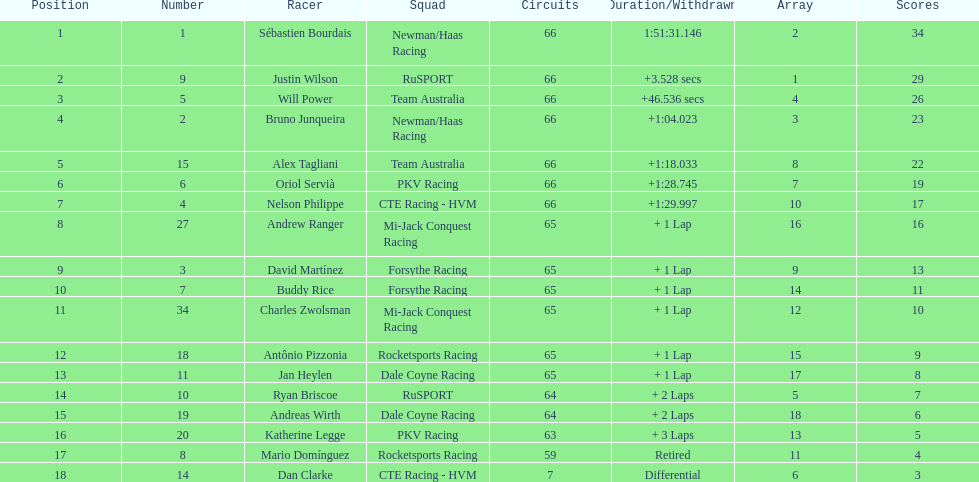Rice finished 10th. who finished next? Charles Zwolsman. Help me parse the entirety of this table. {'header': ['Position', 'Number', 'Racer', 'Squad', 'Circuits', 'Duration/Withdrawn', 'Array', 'Scores'], 'rows': [['1', '1', 'Sébastien Bourdais', 'Newman/Haas Racing', '66', '1:51:31.146', '2', '34'], ['2', '9', 'Justin Wilson', 'RuSPORT', '66', '+3.528 secs', '1', '29'], ['3', '5', 'Will Power', 'Team Australia', '66', '+46.536 secs', '4', '26'], ['4', '2', 'Bruno Junqueira', 'Newman/Haas Racing', '66', '+1:04.023', '3', '23'], ['5', '15', 'Alex Tagliani', 'Team Australia', '66', '+1:18.033', '8', '22'], ['6', '6', 'Oriol Servià', 'PKV Racing', '66', '+1:28.745', '7', '19'], ['7', '4', 'Nelson Philippe', 'CTE Racing - HVM', '66', '+1:29.997', '10', '17'], ['8', '27', 'Andrew Ranger', 'Mi-Jack Conquest Racing', '65', '+ 1 Lap', '16', '16'], ['9', '3', 'David Martínez', 'Forsythe Racing', '65', '+ 1 Lap', '9', '13'], ['10', '7', 'Buddy Rice', 'Forsythe Racing', '65', '+ 1 Lap', '14', '11'], ['11', '34', 'Charles Zwolsman', 'Mi-Jack Conquest Racing', '65', '+ 1 Lap', '12', '10'], ['12', '18', 'Antônio Pizzonia', 'Rocketsports Racing', '65', '+ 1 Lap', '15', '9'], ['13', '11', 'Jan Heylen', 'Dale Coyne Racing', '65', '+ 1 Lap', '17', '8'], ['14', '10', 'Ryan Briscoe', 'RuSPORT', '64', '+ 2 Laps', '5', '7'], ['15', '19', 'Andreas Wirth', 'Dale Coyne Racing', '64', '+ 2 Laps', '18', '6'], ['16', '20', 'Katherine Legge', 'PKV Racing', '63', '+ 3 Laps', '13', '5'], ['17', '8', 'Mario Domínguez', 'Rocketsports Racing', '59', 'Retired', '11', '4'], ['18', '14', 'Dan Clarke', 'CTE Racing - HVM', '7', 'Differential', '6', '3']]} 